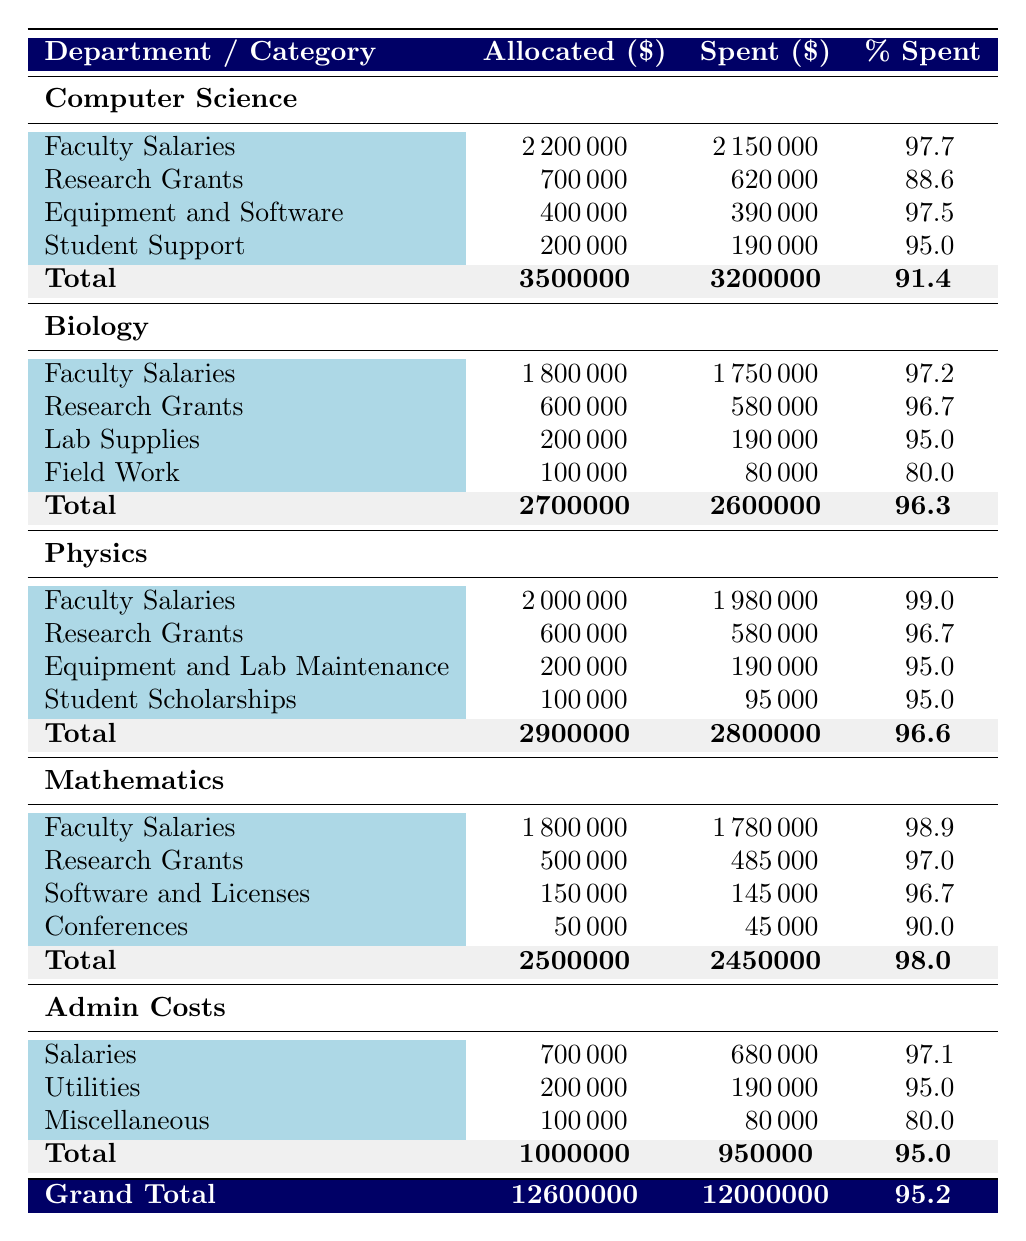What was the total allocated budget for the Computer Science department? The allocated budget for the Computer Science department is stated in the table as 3,500,000.
Answer: 3,500,000 What percentage of the allocated budget did the Biology department spend? The Biology department has a spent budget of 2,600,000 out of an allocated budget of 2,700,000. To find the percentage spent, the formula is (Spent / Allocated) * 100. So (2,600,000 / 2,700,000) * 100 = 96.3%.
Answer: 96.3% Did the Physics department spend more on Faculty Salaries than on Research Grants? The Physics department spent 1,980,000 on Faculty Salaries and 580,000 on Research Grants. Since 1,980,000 is more than 580,000, the answer is yes.
Answer: Yes What is the total amount spent across all departments? Adding the spent budgets: 3,200,000 (Computer Science) + 2,600,000 (Biology) + 2,800,000 (Physics) + 2,450,000 (Mathematics) + 950,000 (Admin Costs) gives a total of 12,000,000.
Answer: 12,000,000 What is the average percentage spent across all departments? The percentages spent for each department are: 91.4% (Computer Science), 96.3% (Biology), 96.6% (Physics), 98.0% (Mathematics), and 95.0% (Admin Costs). To find the average, sum these percentages: 91.4 + 96.3 + 96.6 + 98.0 + 95.0 = 477.3, and then divide by the number of departments, which is 5. So, 477.3 / 5 = 95.46%.
Answer: 95.46% Which department had the highest percentage spent, and what was that percentage? The percentages are: Computer Science 91.4%, Biology 96.3%, Physics 96.6%, Mathematics 98.0%, Admin Costs 95.0%. The highest percentage is from the Mathematics department at 98.0%.
Answer: Mathematics, 98.0% 